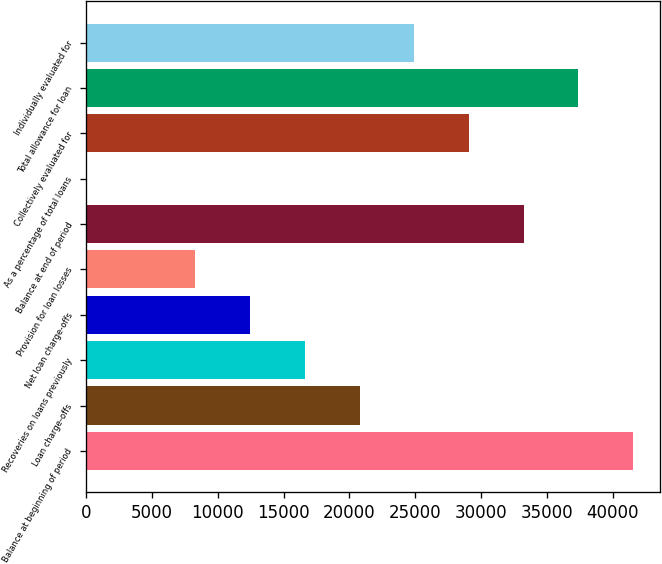Convert chart. <chart><loc_0><loc_0><loc_500><loc_500><bar_chart><fcel>Balance at beginning of period<fcel>Loan charge-offs<fcel>Recoveries on loans previously<fcel>Net loan charge-offs<fcel>Provision for loan losses<fcel>Balance at end of period<fcel>As a percentage of total loans<fcel>Collectively evaluated for<fcel>Total allowance for loan<fcel>Individually evaluated for<nl><fcel>41536<fcel>20768.6<fcel>16615.2<fcel>12461.7<fcel>8308.22<fcel>33229<fcel>1.28<fcel>29075.6<fcel>37382.5<fcel>24922.1<nl></chart> 